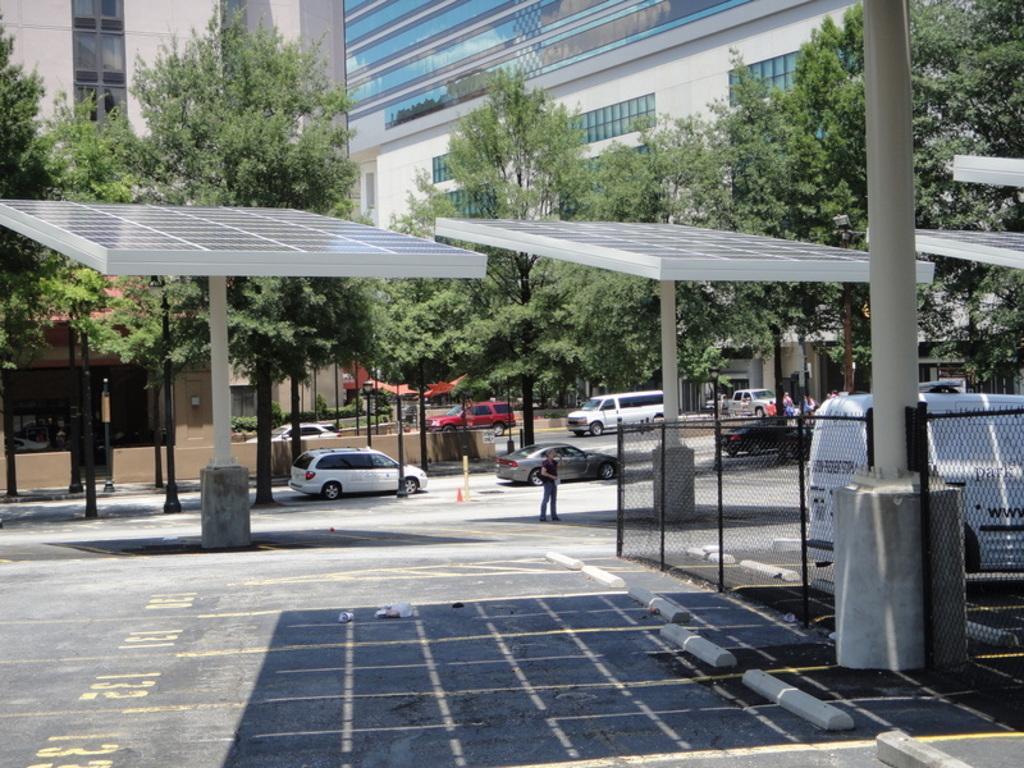In one or two sentences, can you explain what this image depicts? In this image we can see some solar panels in the middle of the image and there are some vehicles on the road. We can see a few buildings and there are few people and we can see some trees and to the right side of the image we can see a fence. 